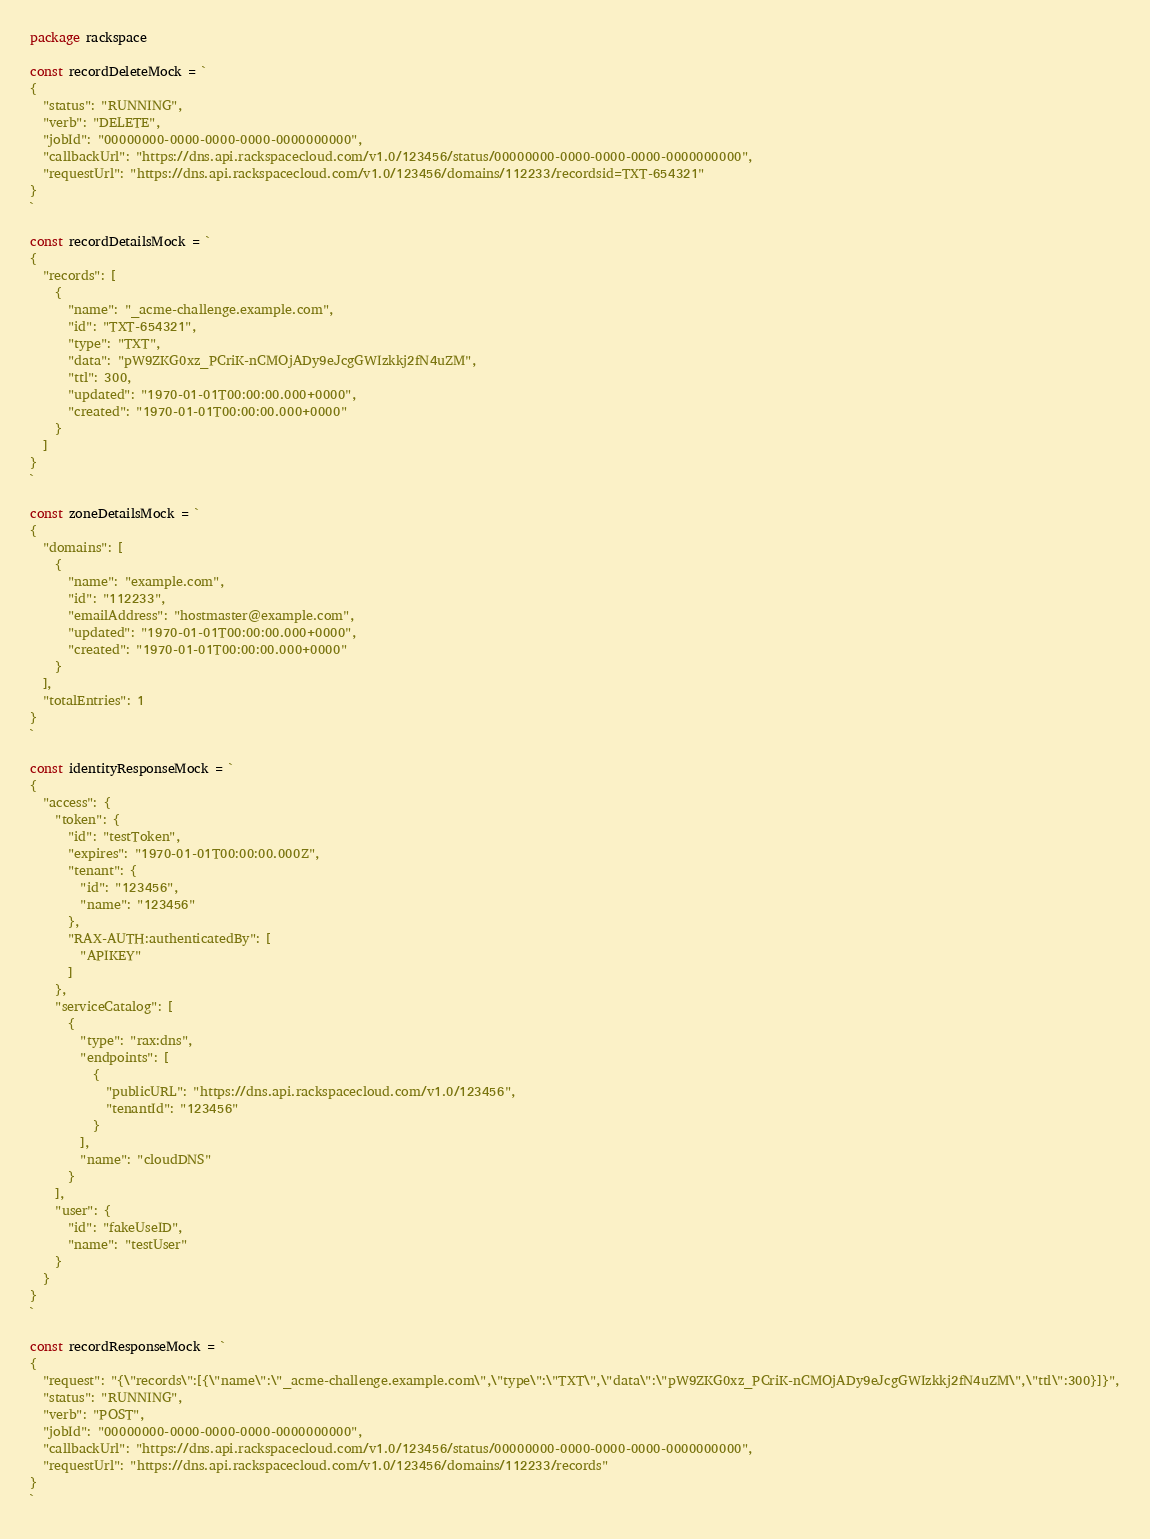<code> <loc_0><loc_0><loc_500><loc_500><_Go_>package rackspace

const recordDeleteMock = `
{
  "status": "RUNNING",
  "verb": "DELETE",
  "jobId": "00000000-0000-0000-0000-0000000000",
  "callbackUrl": "https://dns.api.rackspacecloud.com/v1.0/123456/status/00000000-0000-0000-0000-0000000000",
  "requestUrl": "https://dns.api.rackspacecloud.com/v1.0/123456/domains/112233/recordsid=TXT-654321"
}
`

const recordDetailsMock = `
{
  "records": [
    {
      "name": "_acme-challenge.example.com",
      "id": "TXT-654321",
      "type": "TXT",
      "data": "pW9ZKG0xz_PCriK-nCMOjADy9eJcgGWIzkkj2fN4uZM",
      "ttl": 300,
      "updated": "1970-01-01T00:00:00.000+0000",
      "created": "1970-01-01T00:00:00.000+0000"
    }
  ]
}
`

const zoneDetailsMock = `
{
  "domains": [
    {
      "name": "example.com",
      "id": "112233",
      "emailAddress": "hostmaster@example.com",
      "updated": "1970-01-01T00:00:00.000+0000",
      "created": "1970-01-01T00:00:00.000+0000"
    }
  ],
  "totalEntries": 1
}
`

const identityResponseMock = `
{
  "access": {
    "token": {
      "id": "testToken",
      "expires": "1970-01-01T00:00:00.000Z",
      "tenant": {
        "id": "123456",
        "name": "123456"
      },
      "RAX-AUTH:authenticatedBy": [
        "APIKEY"
      ]
    },
    "serviceCatalog": [
      {
        "type": "rax:dns",
        "endpoints": [
          {
            "publicURL": "https://dns.api.rackspacecloud.com/v1.0/123456",
            "tenantId": "123456"
          }
        ],
        "name": "cloudDNS"
      }
    ],
    "user": {
      "id": "fakeUseID",
      "name": "testUser"
    }
  }
}
`

const recordResponseMock = `
{
  "request": "{\"records\":[{\"name\":\"_acme-challenge.example.com\",\"type\":\"TXT\",\"data\":\"pW9ZKG0xz_PCriK-nCMOjADy9eJcgGWIzkkj2fN4uZM\",\"ttl\":300}]}",
  "status": "RUNNING",
  "verb": "POST",
  "jobId": "00000000-0000-0000-0000-0000000000",
  "callbackUrl": "https://dns.api.rackspacecloud.com/v1.0/123456/status/00000000-0000-0000-0000-0000000000",
  "requestUrl": "https://dns.api.rackspacecloud.com/v1.0/123456/domains/112233/records"
}
`
</code> 